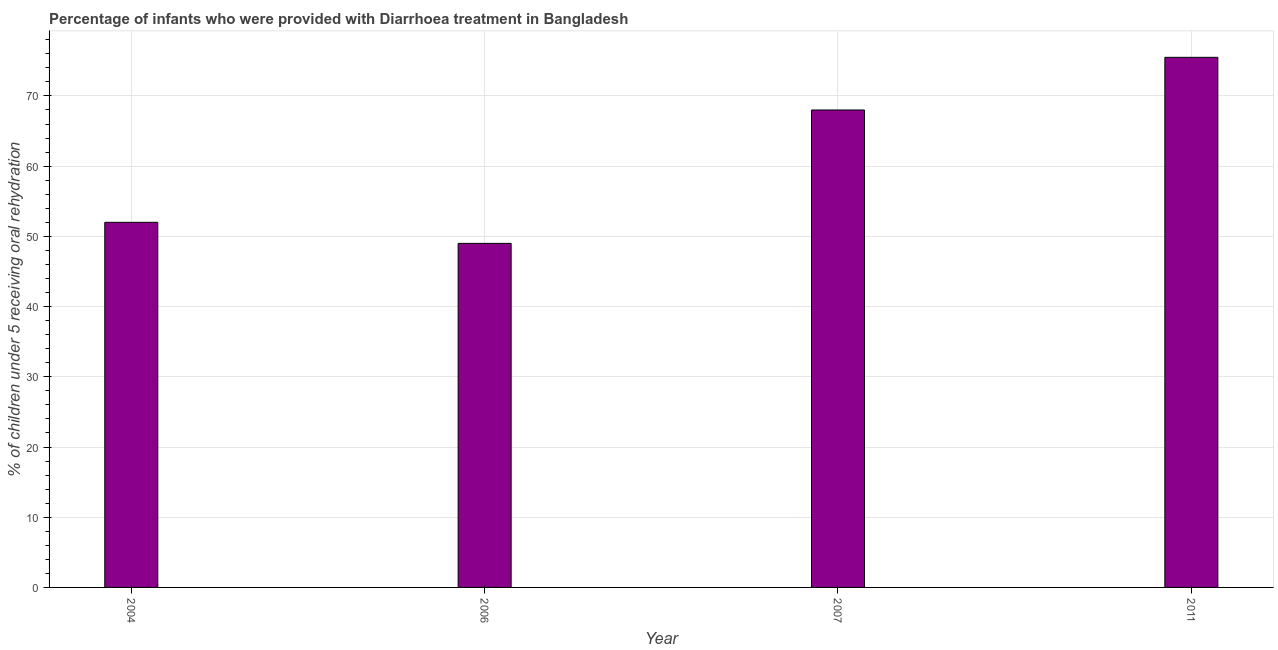Does the graph contain any zero values?
Offer a terse response. No. Does the graph contain grids?
Provide a succinct answer. Yes. What is the title of the graph?
Keep it short and to the point. Percentage of infants who were provided with Diarrhoea treatment in Bangladesh. What is the label or title of the Y-axis?
Provide a succinct answer. % of children under 5 receiving oral rehydration. What is the percentage of children who were provided with treatment diarrhoea in 2007?
Ensure brevity in your answer.  68. Across all years, what is the maximum percentage of children who were provided with treatment diarrhoea?
Provide a short and direct response. 75.5. What is the sum of the percentage of children who were provided with treatment diarrhoea?
Provide a succinct answer. 244.5. What is the difference between the percentage of children who were provided with treatment diarrhoea in 2006 and 2011?
Offer a terse response. -26.5. What is the average percentage of children who were provided with treatment diarrhoea per year?
Give a very brief answer. 61.12. What is the median percentage of children who were provided with treatment diarrhoea?
Ensure brevity in your answer.  60. In how many years, is the percentage of children who were provided with treatment diarrhoea greater than 8 %?
Offer a very short reply. 4. Do a majority of the years between 2007 and 2004 (inclusive) have percentage of children who were provided with treatment diarrhoea greater than 70 %?
Your response must be concise. Yes. What is the ratio of the percentage of children who were provided with treatment diarrhoea in 2006 to that in 2011?
Provide a short and direct response. 0.65. What is the difference between the highest and the lowest percentage of children who were provided with treatment diarrhoea?
Your answer should be compact. 26.5. Are all the bars in the graph horizontal?
Ensure brevity in your answer.  No. How many years are there in the graph?
Offer a terse response. 4. What is the % of children under 5 receiving oral rehydration in 2006?
Your answer should be very brief. 49. What is the % of children under 5 receiving oral rehydration of 2007?
Give a very brief answer. 68. What is the % of children under 5 receiving oral rehydration in 2011?
Provide a short and direct response. 75.5. What is the difference between the % of children under 5 receiving oral rehydration in 2004 and 2011?
Keep it short and to the point. -23.5. What is the difference between the % of children under 5 receiving oral rehydration in 2006 and 2007?
Ensure brevity in your answer.  -19. What is the difference between the % of children under 5 receiving oral rehydration in 2006 and 2011?
Your answer should be compact. -26.5. What is the difference between the % of children under 5 receiving oral rehydration in 2007 and 2011?
Your answer should be very brief. -7.5. What is the ratio of the % of children under 5 receiving oral rehydration in 2004 to that in 2006?
Your answer should be compact. 1.06. What is the ratio of the % of children under 5 receiving oral rehydration in 2004 to that in 2007?
Offer a very short reply. 0.77. What is the ratio of the % of children under 5 receiving oral rehydration in 2004 to that in 2011?
Make the answer very short. 0.69. What is the ratio of the % of children under 5 receiving oral rehydration in 2006 to that in 2007?
Provide a short and direct response. 0.72. What is the ratio of the % of children under 5 receiving oral rehydration in 2006 to that in 2011?
Keep it short and to the point. 0.65. What is the ratio of the % of children under 5 receiving oral rehydration in 2007 to that in 2011?
Your answer should be compact. 0.9. 